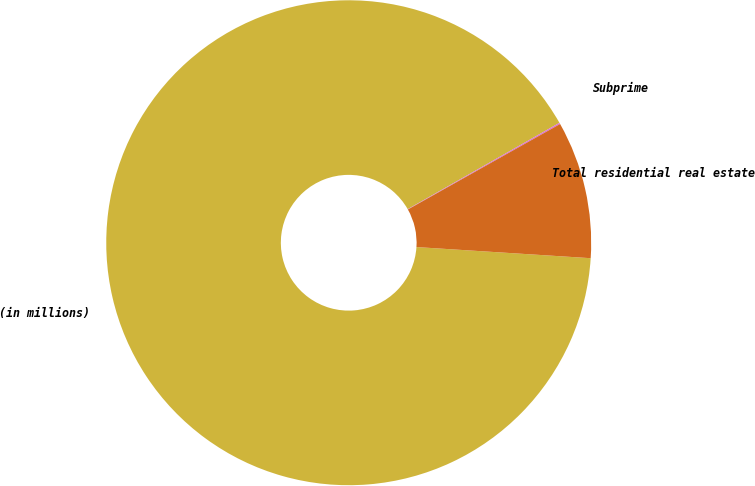<chart> <loc_0><loc_0><loc_500><loc_500><pie_chart><fcel>(in millions)<fcel>Subprime<fcel>Total residential real estate<nl><fcel>90.75%<fcel>0.09%<fcel>9.16%<nl></chart> 